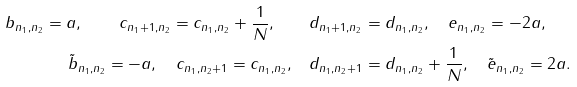Convert formula to latex. <formula><loc_0><loc_0><loc_500><loc_500>b _ { n _ { 1 } , n _ { 2 } } = a , \quad c _ { n _ { 1 } + 1 , n _ { 2 } } = c _ { n _ { 1 } , n _ { 2 } } + \frac { 1 } { N } , \quad & d _ { n _ { 1 } + 1 , n _ { 2 } } = d _ { n _ { 1 } , n _ { 2 } } , \quad e _ { n _ { 1 } , n _ { 2 } } = - 2 a , \\ \tilde { b } _ { n _ { 1 } , n _ { 2 } } = - a , \quad c _ { n _ { 1 } , n _ { 2 } + 1 } = c _ { n _ { 1 } , n _ { 2 } } , \quad & d _ { n _ { 1 } , n _ { 2 } + 1 } = d _ { n _ { 1 } , n _ { 2 } } + \frac { 1 } { N } , \quad \tilde { e } _ { n _ { 1 } , n _ { 2 } } = 2 a .</formula> 